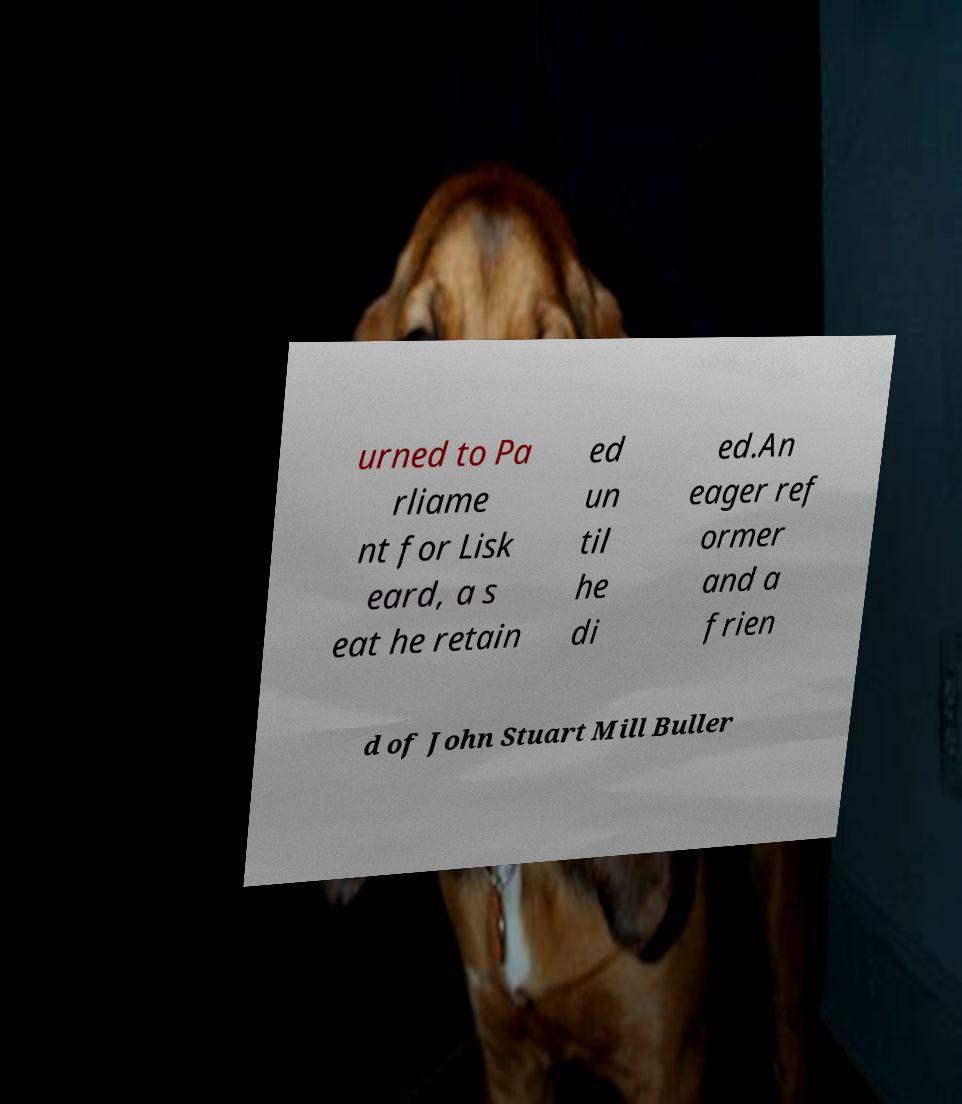What messages or text are displayed in this image? I need them in a readable, typed format. urned to Pa rliame nt for Lisk eard, a s eat he retain ed un til he di ed.An eager ref ormer and a frien d of John Stuart Mill Buller 